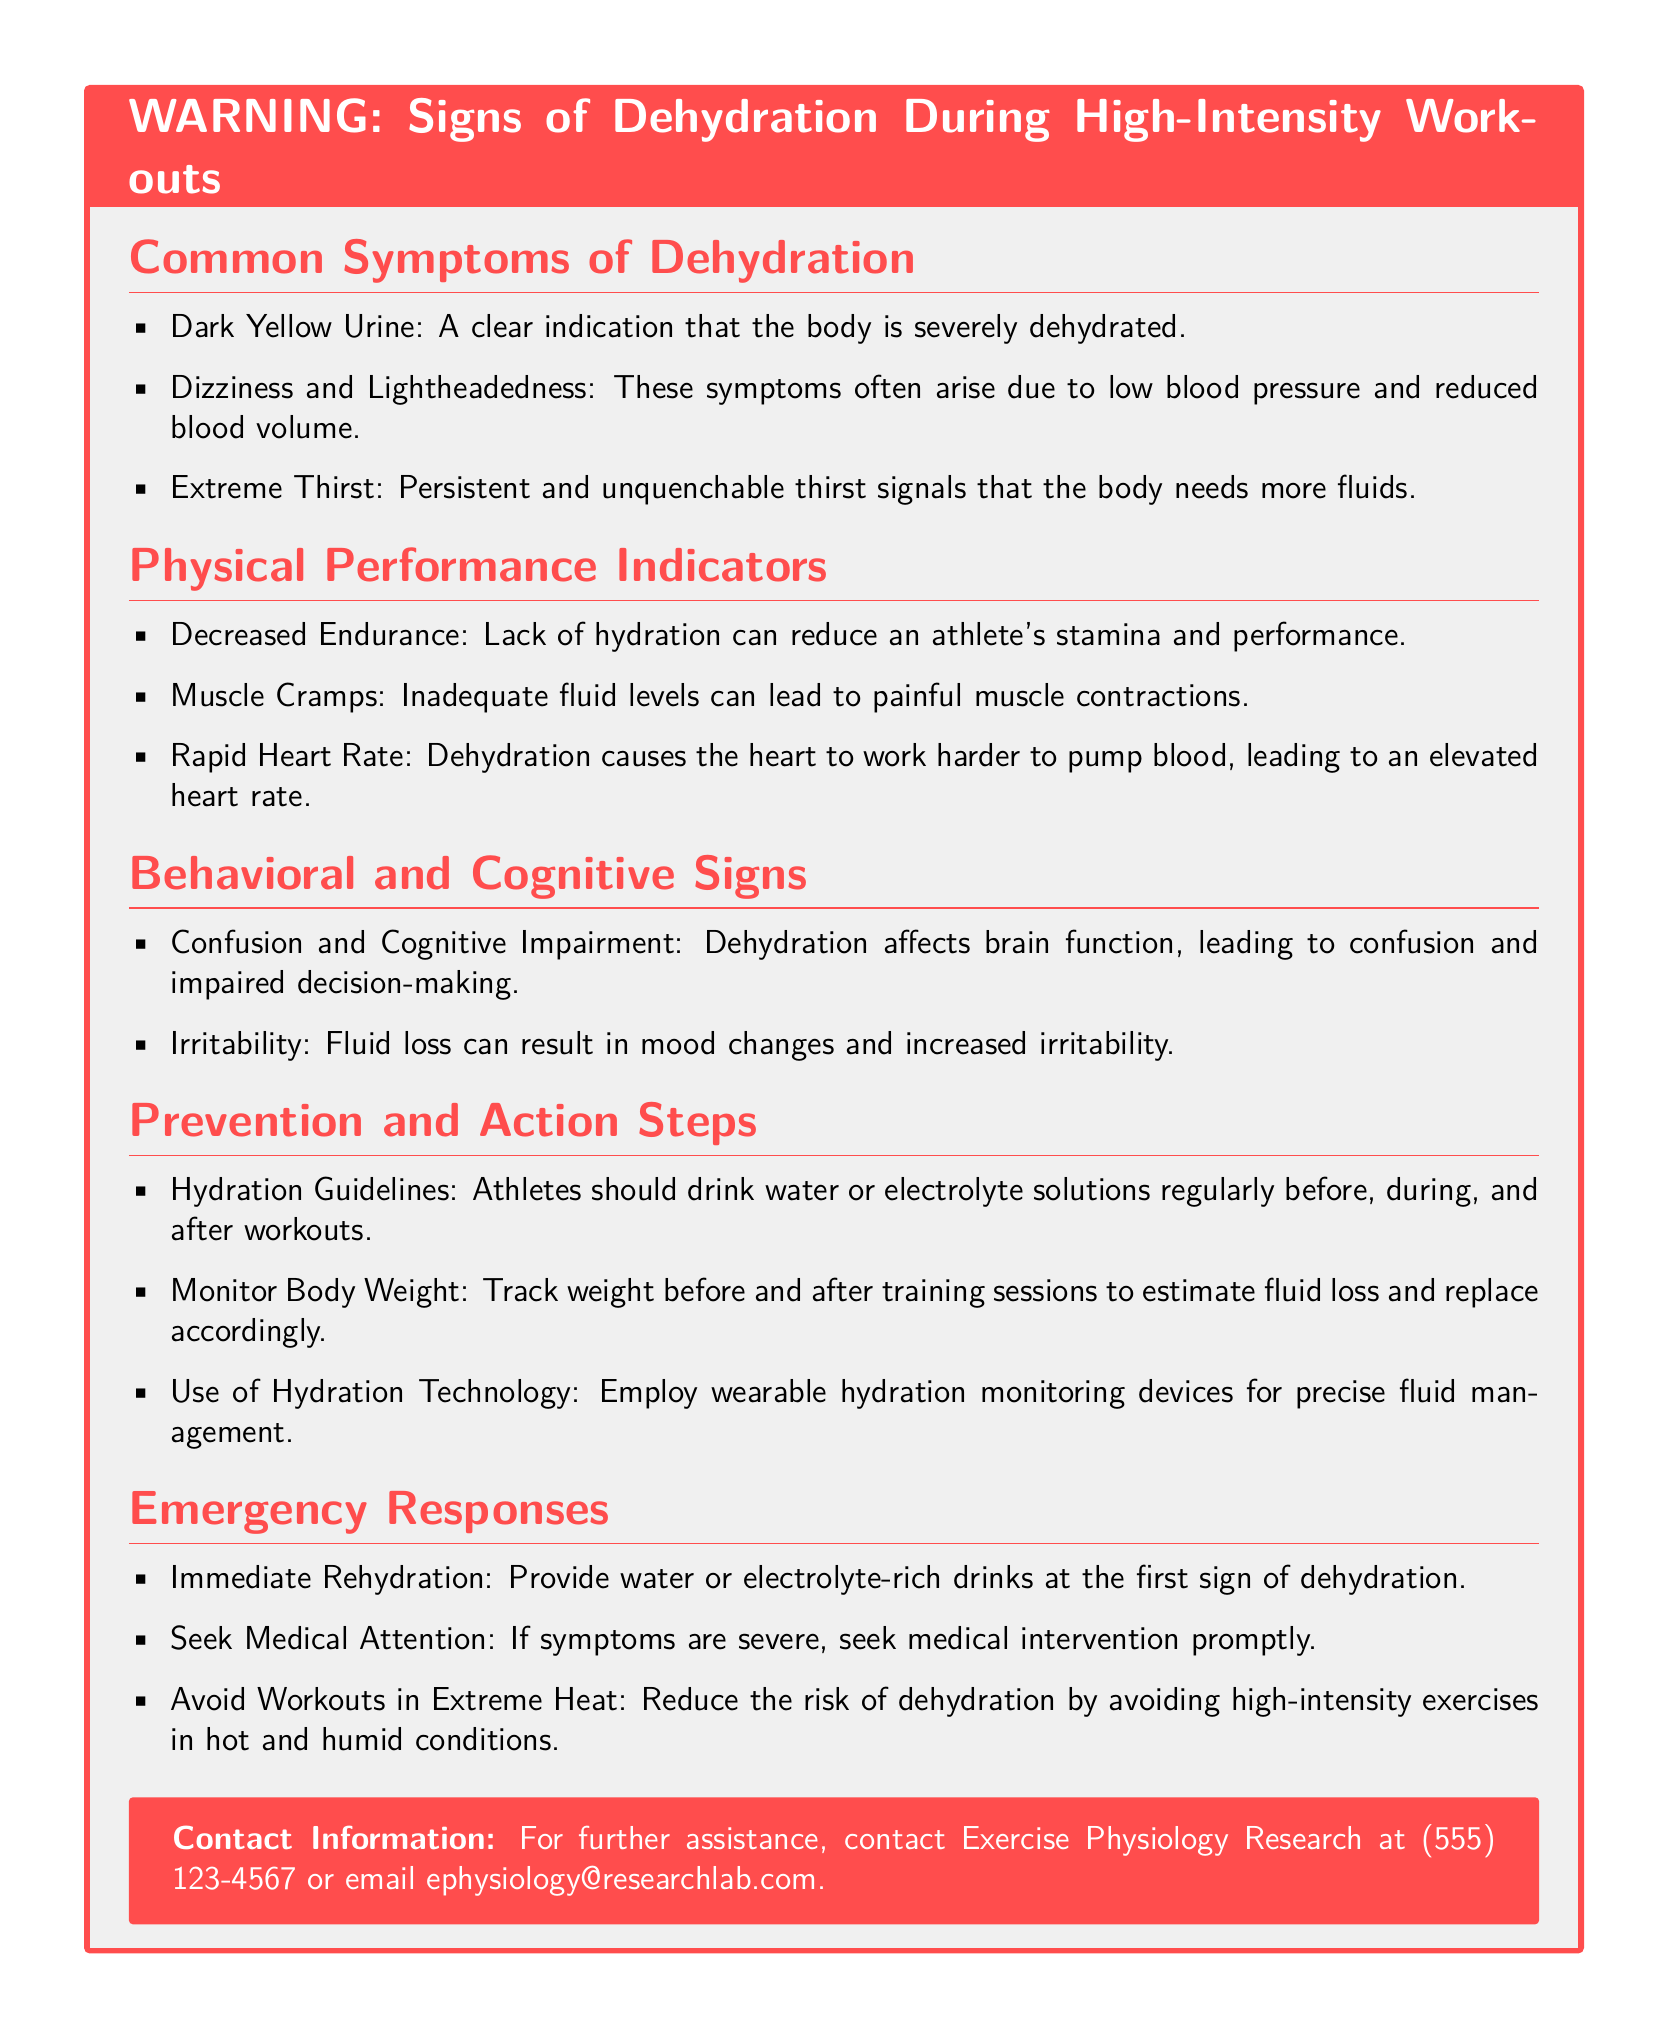What is a clear indication of dehydration? The warning label states that dark yellow urine is a clear indication that the body is severely dehydrated.
Answer: Dark Yellow Urine What is a physical performance indicator of dehydration? The document lists decreased endurance as one of the physical performance indicators affected by dehydration.
Answer: Decreased Endurance What behavioral sign indicates dehydration? The label mentions confusion and cognitive impairment as behavioral signs of dehydration.
Answer: Confusion and Cognitive Impairment What hydration guideline is recommended for athletes? The document suggests that athletes should drink water or electrolyte solutions regularly before, during, and after workouts.
Answer: Hydration Guidelines What should be done at the first sign of dehydration? The recommended action is to provide water or electrolyte-rich drinks at the first sign of dehydration.
Answer: Immediate Rehydration What action can help reduce the risk of dehydration? The warning label advises avoiding high-intensity exercises in hot and humid conditions to reduce dehydration risk.
Answer: Avoid Workouts in Extreme Heat How can athletes monitor fluid loss during training? The document states that tracking weight before and after training sessions can help estimate fluid loss.
Answer: Monitor Body Weight What color of urine indicates severe dehydration? The warning label specifies that dark yellow urine indicates severe dehydration.
Answer: Dark Yellow Urine What response is recommended if symptoms of dehydration are severe? According to the document, seeking medical attention is the recommended response if symptoms are severe.
Answer: Seek Medical Attention 